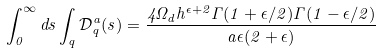<formula> <loc_0><loc_0><loc_500><loc_500>\int _ { 0 } ^ { \infty } d s \int _ { q } \mathcal { D } _ { q } ^ { a } ( s ) = \frac { 4 \Omega _ { d } h ^ { \epsilon + 2 } \Gamma ( 1 + \epsilon / 2 ) \Gamma ( 1 - \epsilon / 2 ) } { a \epsilon ( 2 + \epsilon ) }</formula> 